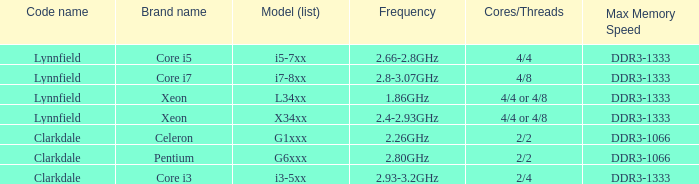List the number of cores for ddr3-1333 with frequencies between 2.66-2.8ghz. 4/4. 